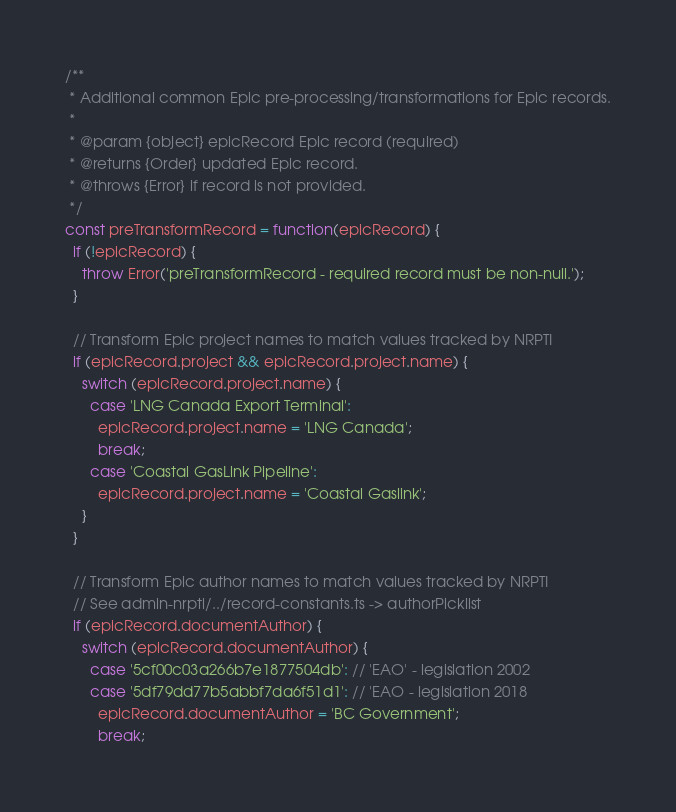Convert code to text. <code><loc_0><loc_0><loc_500><loc_500><_JavaScript_>/**
 * Additional common Epic pre-processing/transformations for Epic records.
 *
 * @param {object} epicRecord Epic record (required)
 * @returns {Order} updated Epic record.
 * @throws {Error} if record is not provided.
 */
const preTransformRecord = function(epicRecord) {
  if (!epicRecord) {
    throw Error('preTransformRecord - required record must be non-null.');
  }

  // Transform Epic project names to match values tracked by NRPTI
  if (epicRecord.project && epicRecord.project.name) {
    switch (epicRecord.project.name) {
      case 'LNG Canada Export Terminal':
        epicRecord.project.name = 'LNG Canada';
        break;
      case 'Coastal GasLink Pipeline':
        epicRecord.project.name = 'Coastal Gaslink';
    }
  }

  // Transform Epic author names to match values tracked by NRPTI
  // See admin-nrpti/../record-constants.ts -> authorPicklist
  if (epicRecord.documentAuthor) {
    switch (epicRecord.documentAuthor) {
      case '5cf00c03a266b7e1877504db': // 'EAO' - legislation 2002
      case '5df79dd77b5abbf7da6f51d1': // 'EAO - legislation 2018
        epicRecord.documentAuthor = 'BC Government';
        break;</code> 